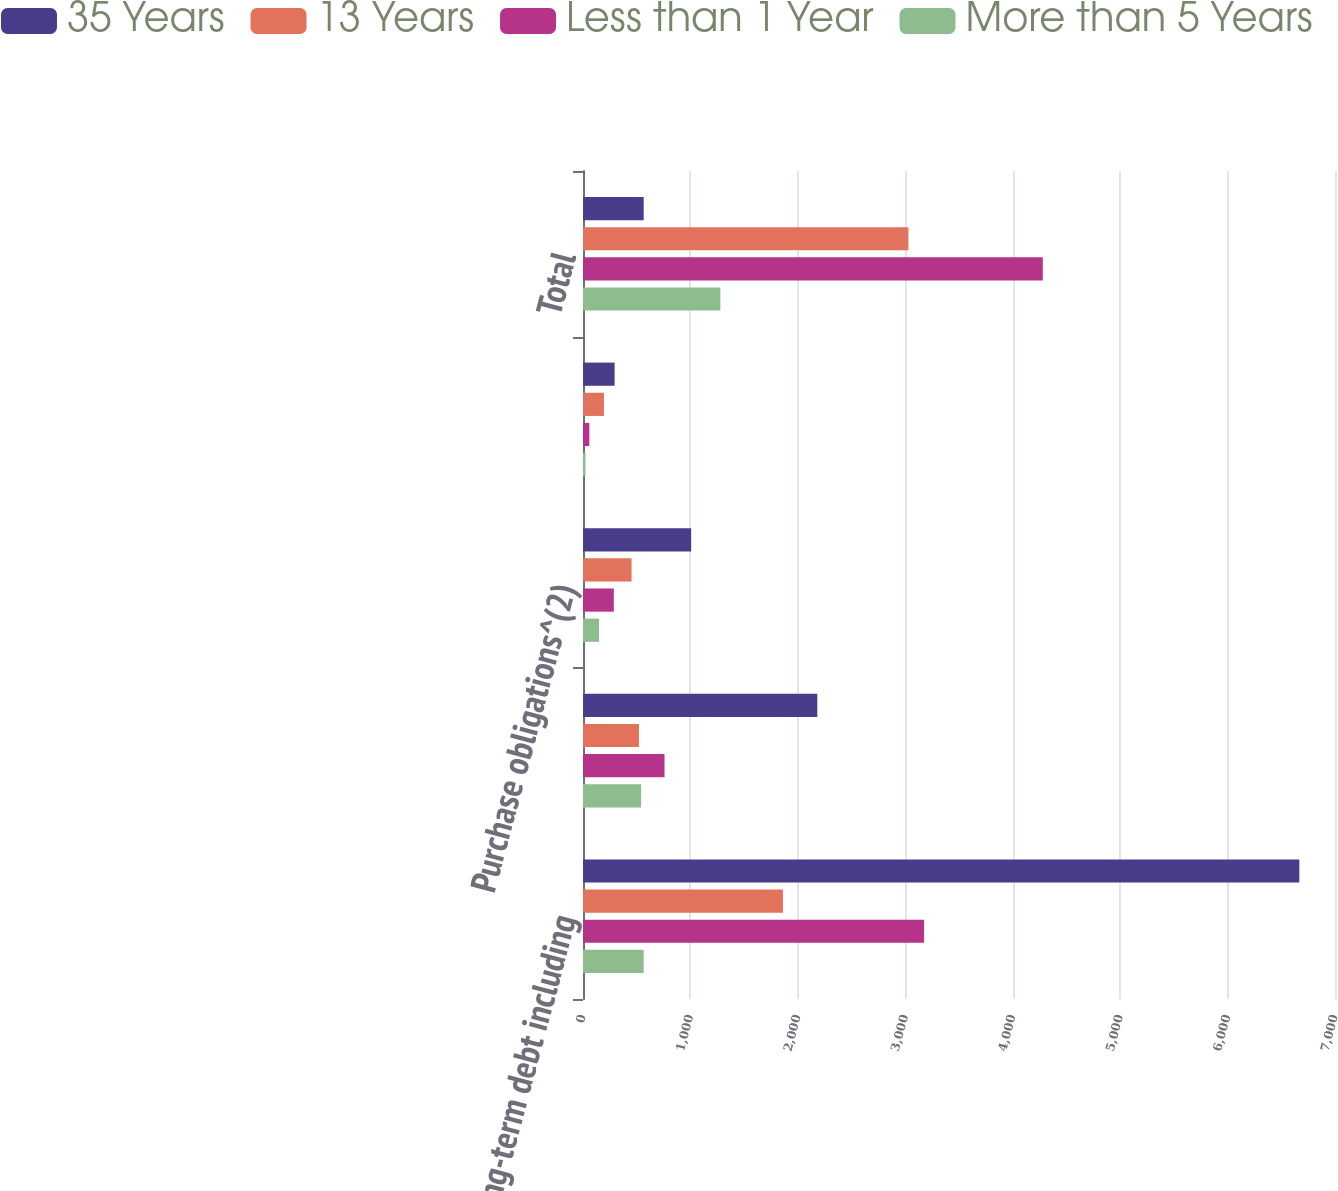Convert chart. <chart><loc_0><loc_0><loc_500><loc_500><stacked_bar_chart><ecel><fcel>Long-term debt including<fcel>Operating lease obligations<fcel>Purchase obligations^(2)<fcel>Restructuring-related<fcel>Total<nl><fcel>35 Years<fcel>6668<fcel>2181<fcel>1007<fcel>294<fcel>565<nl><fcel>13 Years<fcel>1861<fcel>521<fcel>452<fcel>195<fcel>3029<nl><fcel>Less than 1 Year<fcel>3175<fcel>759<fcel>287<fcel>59<fcel>4280<nl><fcel>More than 5 Years<fcel>565<fcel>541<fcel>150<fcel>23<fcel>1279<nl></chart> 